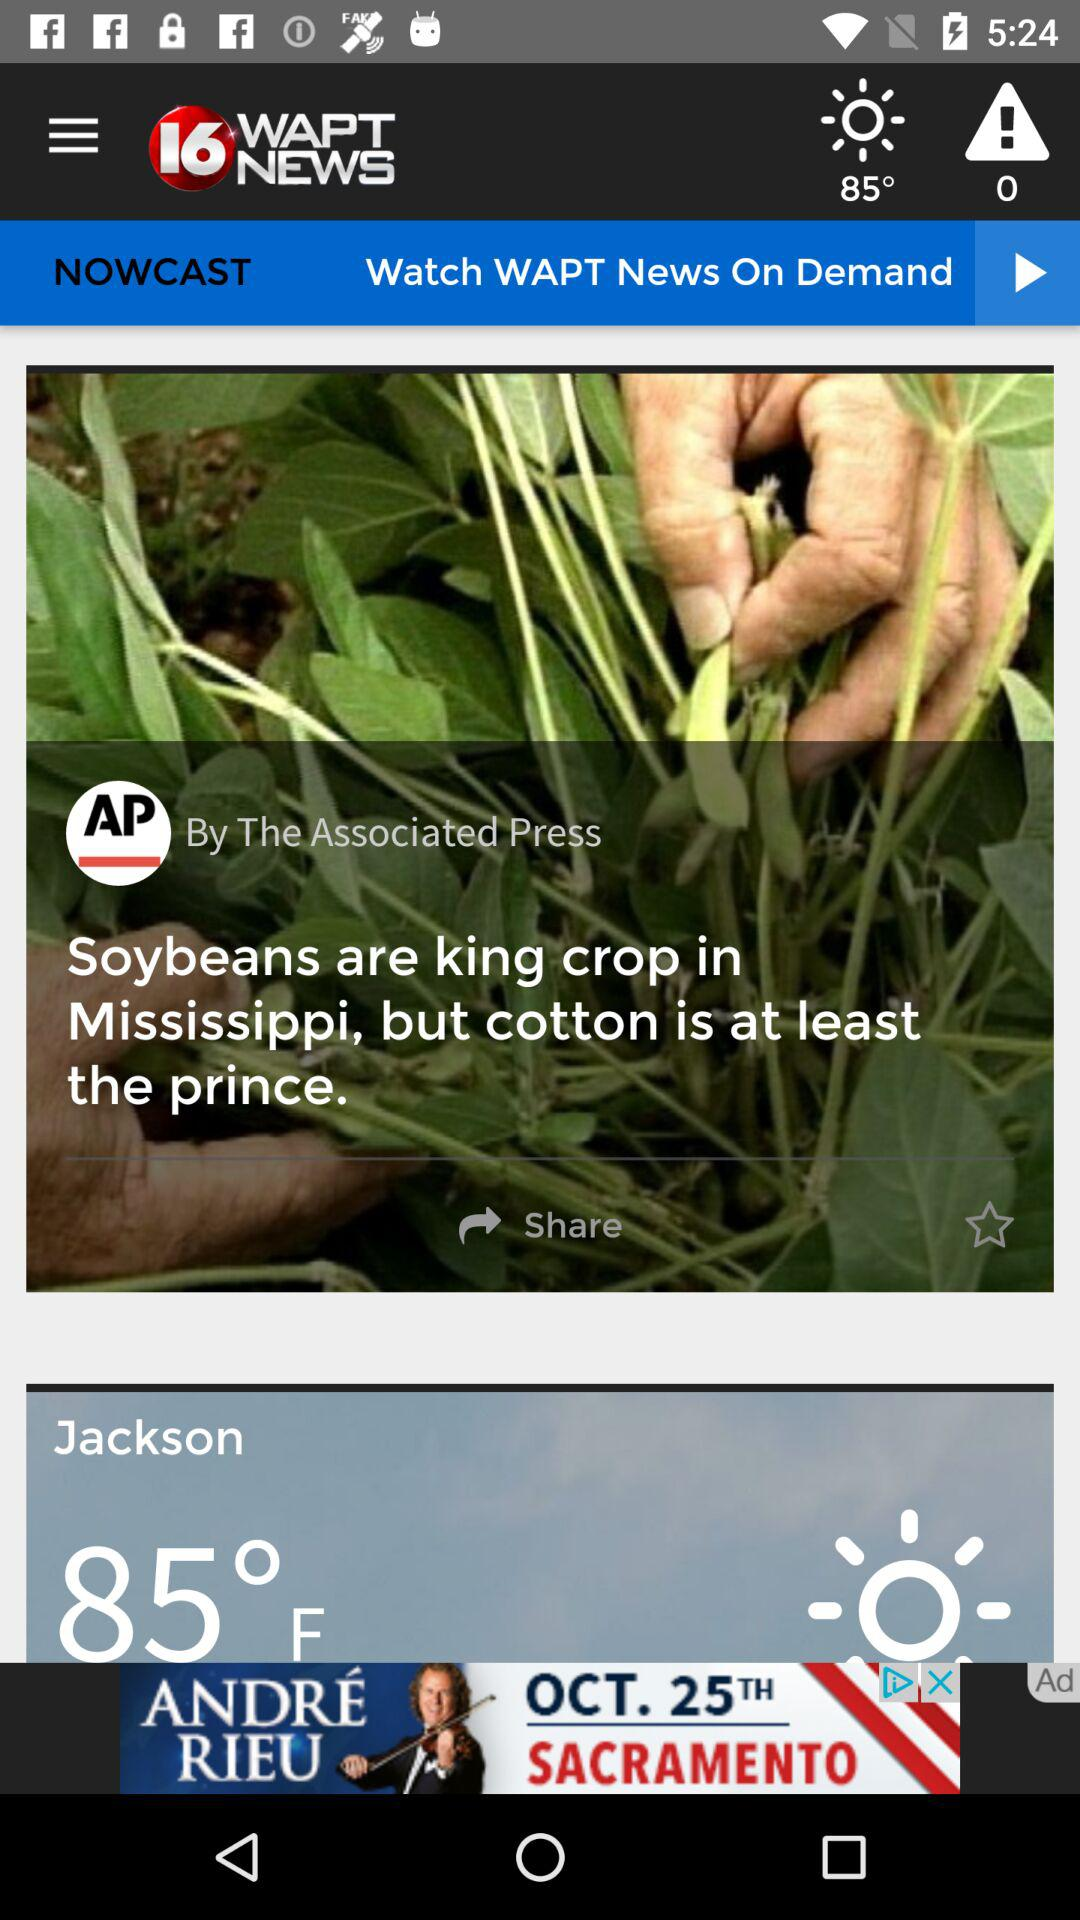What is the weather forecast? The weather forecast is sunny. 